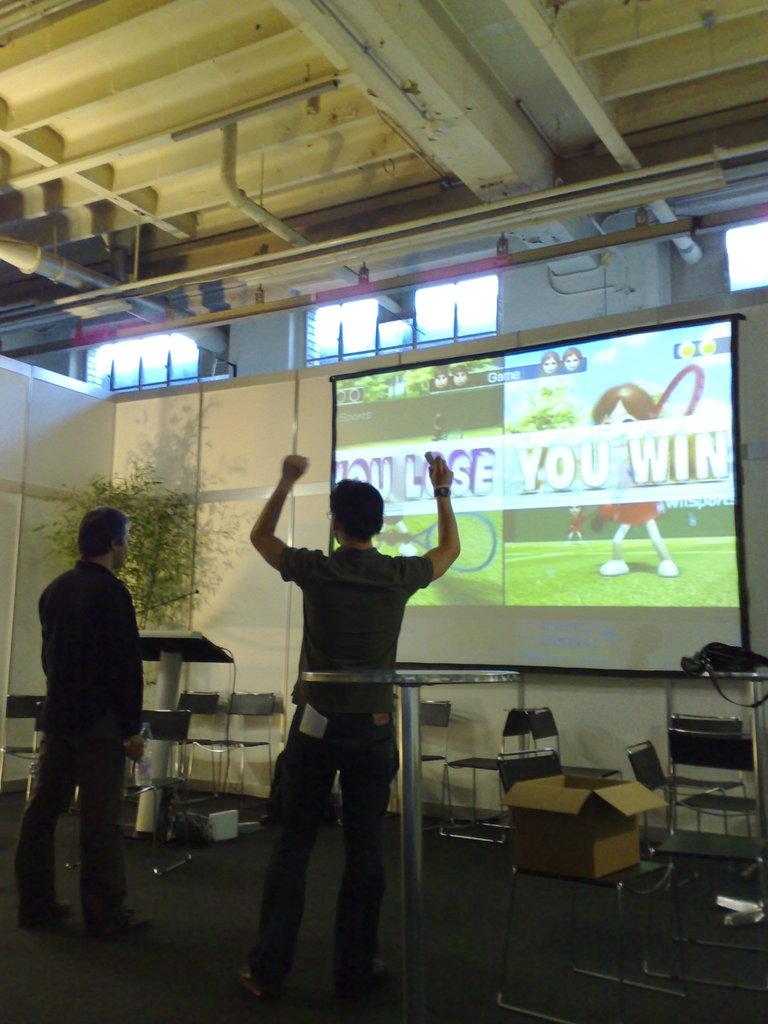What is on the right half of the screen?
Provide a short and direct response. You win. What did the man on the right acheive?
Your answer should be compact. Win. 